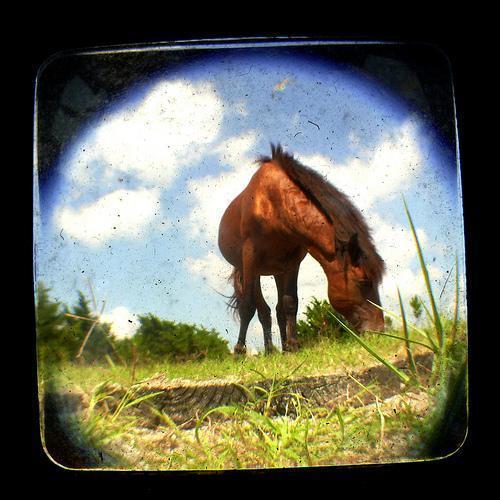How many horses are shown?
Give a very brief answer. 1. 